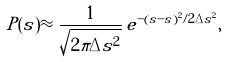<formula> <loc_0><loc_0><loc_500><loc_500>P ( \tilde { s } ) \approx \frac { 1 } { \sqrt { 2 \pi \Delta \tilde { s } ^ { 2 } } } \, e ^ { - ( \tilde { s } - s ) ^ { 2 } / 2 \Delta \tilde { s } ^ { 2 } } ,</formula> 